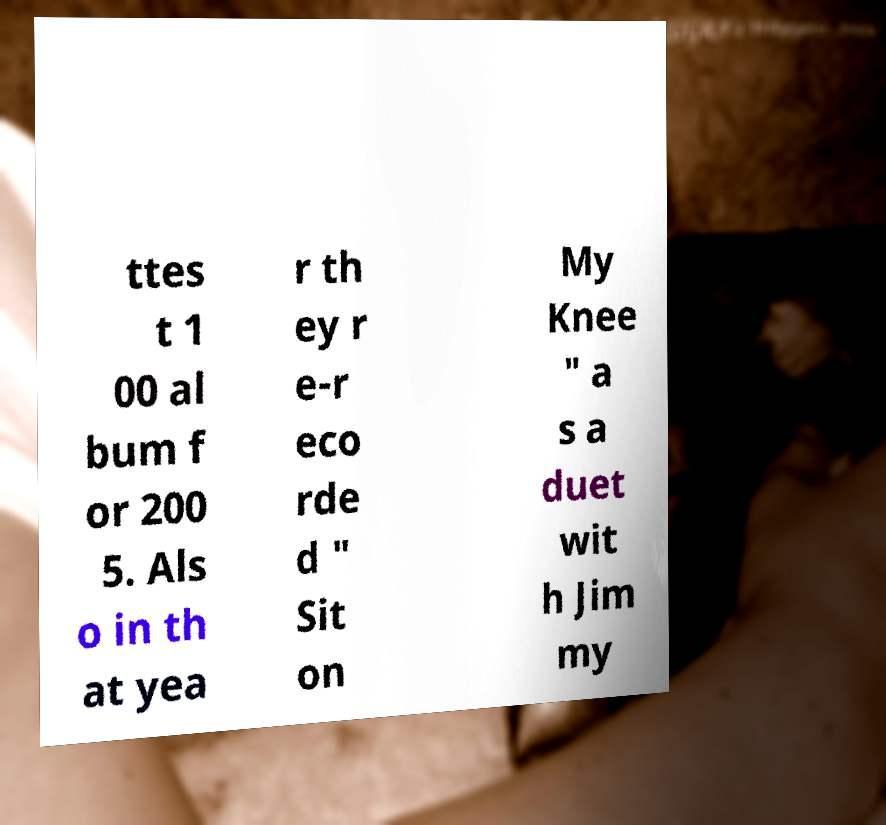I need the written content from this picture converted into text. Can you do that? ttes t 1 00 al bum f or 200 5. Als o in th at yea r th ey r e-r eco rde d " Sit on My Knee " a s a duet wit h Jim my 